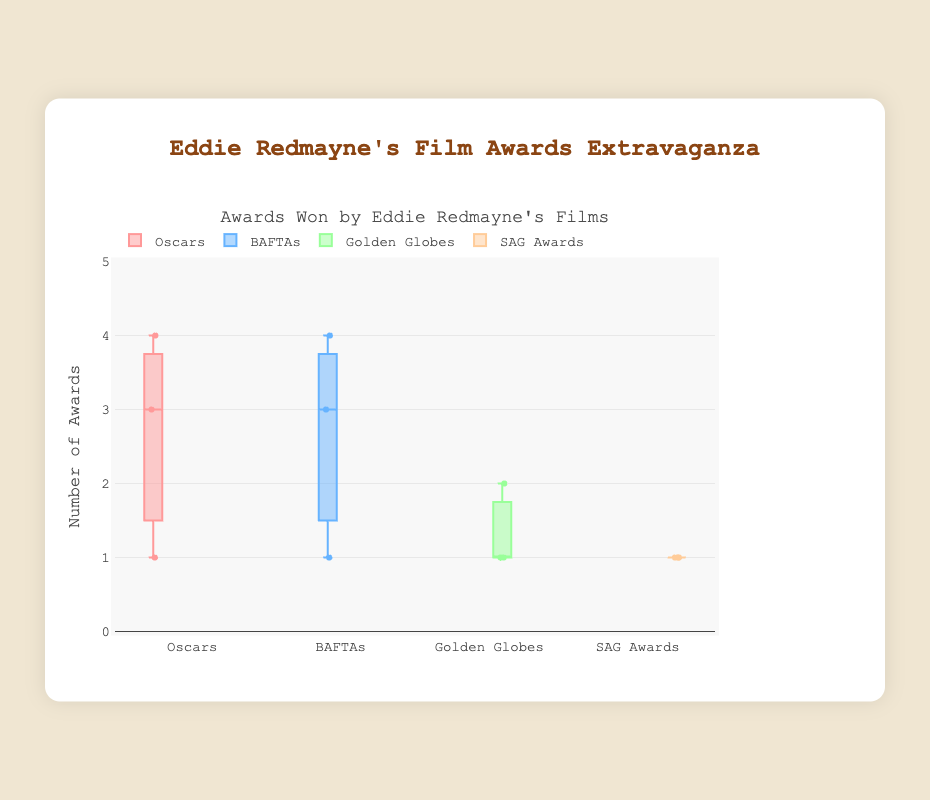What is the title of the box plot? The title of the box plot is displayed at the top of the figure.
Answer: Awards Won by Eddie Redmayne's Films Which award type shows the highest number of awards won by any single movie? To determine this, observe the maximum value of each award type. The highest value in the plot is 4, which is under the "Oscars" category for "The Theory of Everything".
Answer: Oscars How many awards did "Les Misérables" win in total? Sum the awards won by "Les Misérables" in all categories: 3 (Oscars) + 4 (BAFTAs) + 1 (Golden Globes) + 1 (SAG Awards).
Answer: 9 Which movie won the most BAFTAs? Look at the BAFTAs category and identify the movie with the highest number; it’s "Les Misérables" with 4 awards.
Answer: Les Misérables What is the median number of awards won in the BAFTAs category? The BAFTAs data points are [3, 1, 4]. Ordering them gives [1, 3, 4], so the median is the middle value, which is 3.
Answer: 3 Is there any award type where all the movies won an equal number of awards? Check each category; in the "SAG Awards" all movies won exactly 1 award.
Answer: SAG Awards Which award type has the lowest variance in the number of awards won? The "SAG Awards" have the least variance since all movies have an equal number of awards (variance is 0).
Answer: SAG Awards What is the interquartile range (IQR) of the Oscars category? To find the IQR, order the Oscars data points [1, 3, 4]. The first quartile (Q1) is 1, and the third quartile (Q3) is 4. Hence, IQR = Q3 - Q1 = 4 - 1 = 3.
Answer: 3 Which movie won the most awards overall? Sum the awards for each movie: "The Theory of Everything" (4+3+2+1=10), "The Danish Girl" (1+1+1+1=4), "Les Misérables" (3+4+1+1=9). "The Theory of Everything" has the highest total.
Answer: The Theory of Everything 